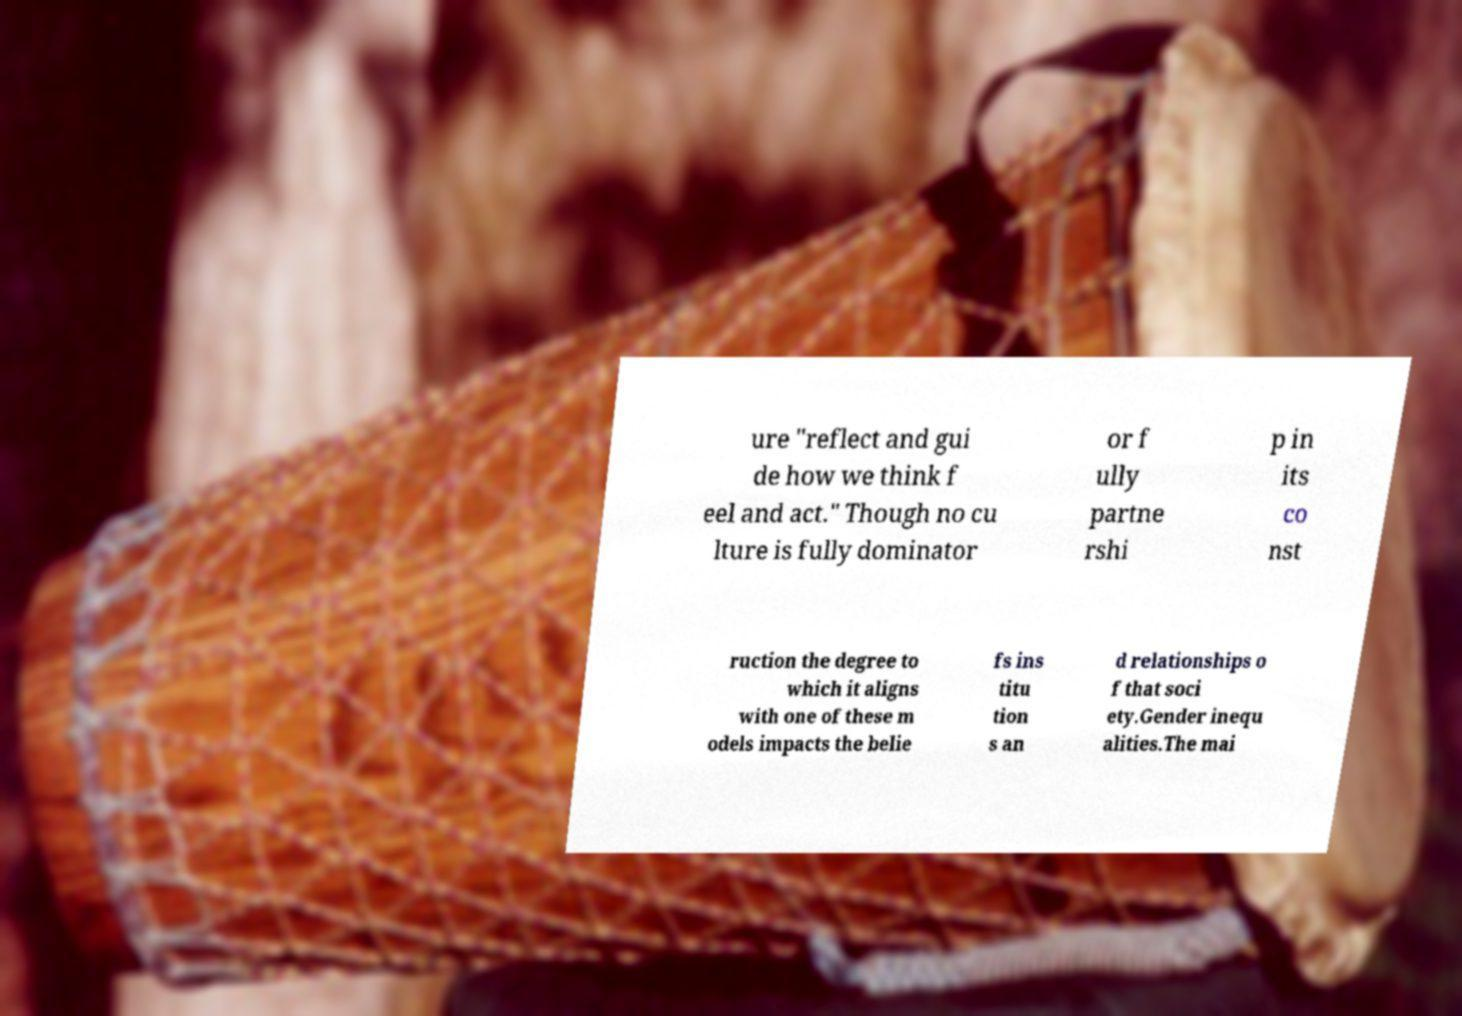What messages or text are displayed in this image? I need them in a readable, typed format. ure "reflect and gui de how we think f eel and act." Though no cu lture is fully dominator or f ully partne rshi p in its co nst ruction the degree to which it aligns with one of these m odels impacts the belie fs ins titu tion s an d relationships o f that soci ety.Gender inequ alities.The mai 